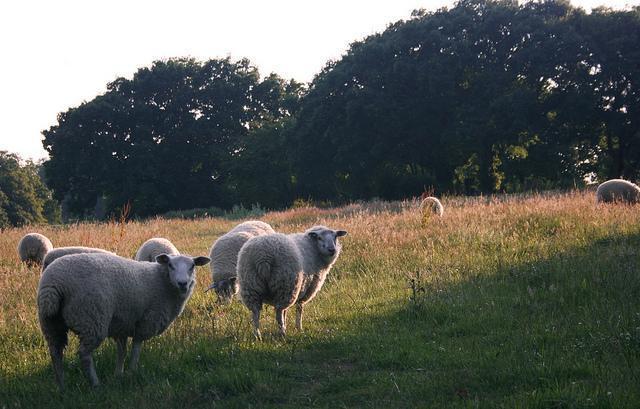How many elephants are shown?
Give a very brief answer. 0. How many sheep are there?
Give a very brief answer. 3. 